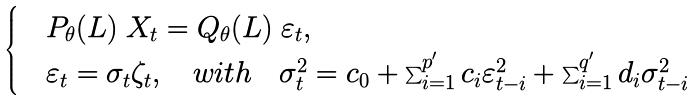Convert formula to latex. <formula><loc_0><loc_0><loc_500><loc_500>\begin{cases} & P _ { \theta } ( L ) \ X _ { t } = Q _ { \theta } ( L ) \ \varepsilon _ { t } , \\ & \varepsilon _ { t } = \sigma _ { t } \zeta _ { t } , \quad w i t h \quad \sigma _ { t } ^ { 2 } = c _ { 0 } + \sum _ { i = 1 } ^ { p ^ { \prime } } c _ { i } \varepsilon _ { t - i } ^ { 2 } + \sum _ { i = 1 } ^ { q ^ { \prime } } d _ { i } \sigma _ { t - i } ^ { 2 } \end{cases}</formula> 